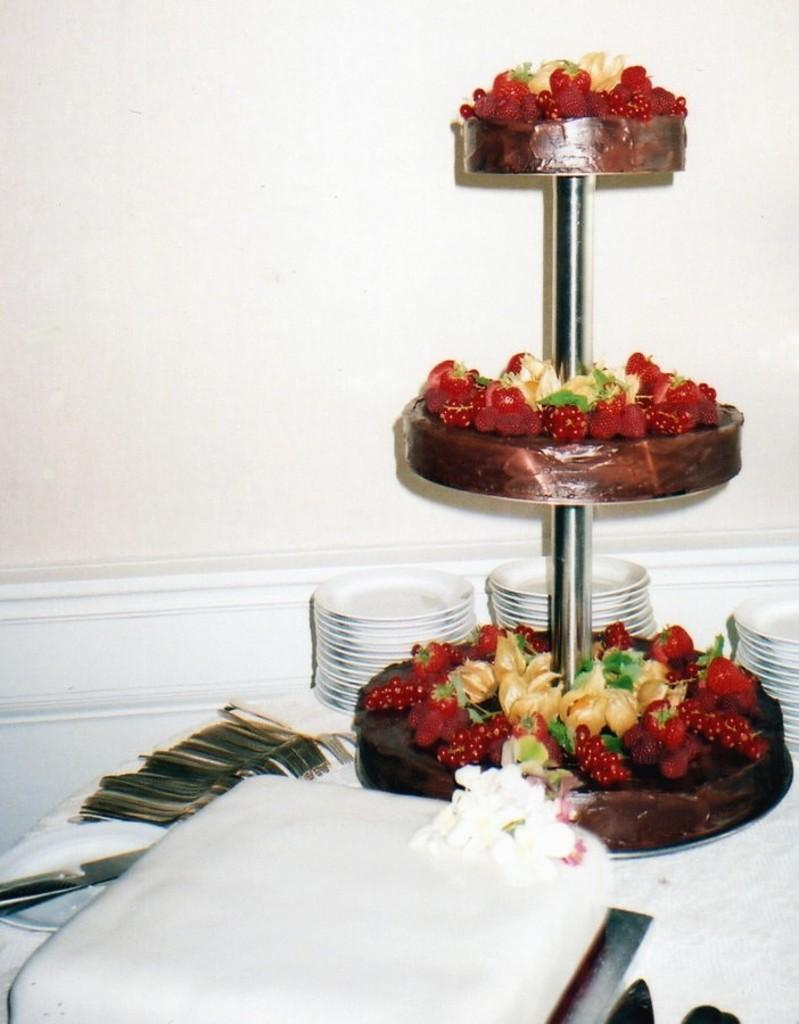What objects are present on the plates in the image? There is a knife on a plate in the image. What type of food is depicted in the image? There are cores and a three-layer cake with strawberries in the image. How many layers does the cake have? The cake has three layers. What decoration is present on the cake? Strawberries are on the cake. What type of apparatus is used to extract minerals from the earth in the image? There is no apparatus or reference to mining or extracting minerals in the image. Can you tell me how many aunts are present in the image? There are no people, including aunts, present in the image. 